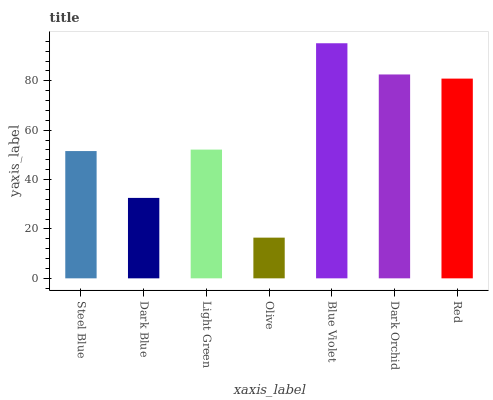Is Olive the minimum?
Answer yes or no. Yes. Is Blue Violet the maximum?
Answer yes or no. Yes. Is Dark Blue the minimum?
Answer yes or no. No. Is Dark Blue the maximum?
Answer yes or no. No. Is Steel Blue greater than Dark Blue?
Answer yes or no. Yes. Is Dark Blue less than Steel Blue?
Answer yes or no. Yes. Is Dark Blue greater than Steel Blue?
Answer yes or no. No. Is Steel Blue less than Dark Blue?
Answer yes or no. No. Is Light Green the high median?
Answer yes or no. Yes. Is Light Green the low median?
Answer yes or no. Yes. Is Steel Blue the high median?
Answer yes or no. No. Is Red the low median?
Answer yes or no. No. 